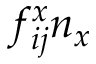Convert formula to latex. <formula><loc_0><loc_0><loc_500><loc_500>f _ { i j } ^ { x } n _ { x }</formula> 